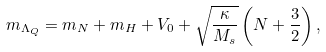<formula> <loc_0><loc_0><loc_500><loc_500>m _ { \Lambda _ { Q } } = m _ { N } + m _ { H } + V _ { 0 } + \sqrt { \frac { \kappa } { M _ { s } } } \left ( N + \frac { 3 } { 2 } \right ) ,</formula> 